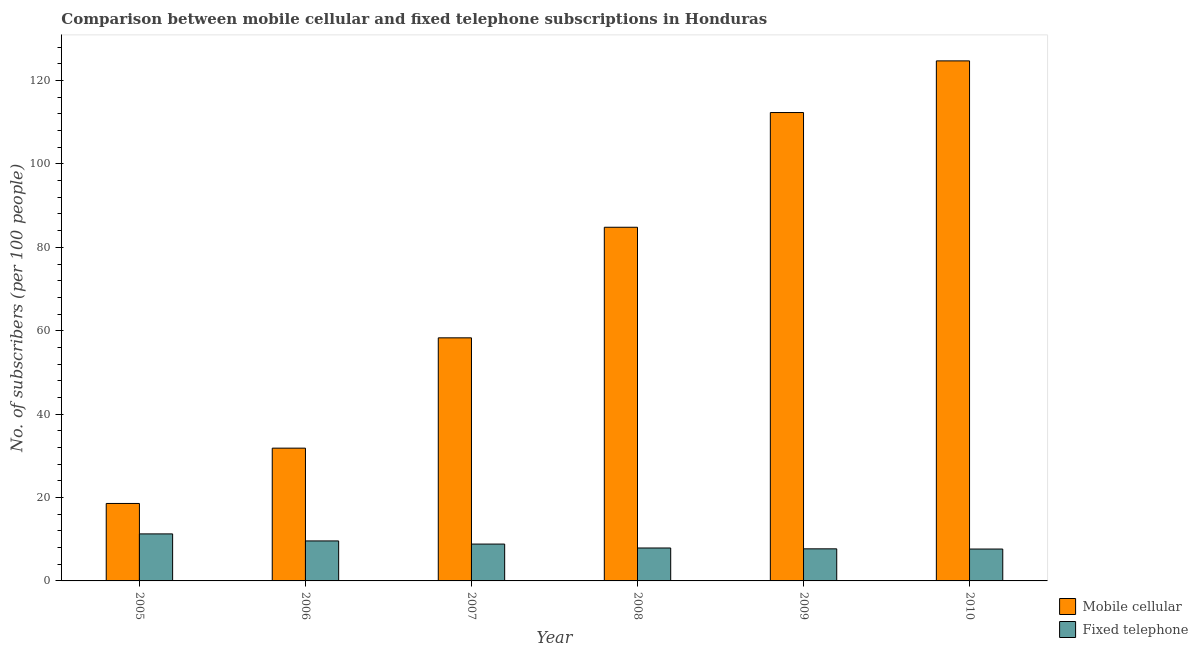How many groups of bars are there?
Keep it short and to the point. 6. Are the number of bars per tick equal to the number of legend labels?
Ensure brevity in your answer.  Yes. Are the number of bars on each tick of the X-axis equal?
Your answer should be compact. Yes. How many bars are there on the 6th tick from the left?
Your answer should be very brief. 2. How many bars are there on the 4th tick from the right?
Offer a very short reply. 2. What is the label of the 3rd group of bars from the left?
Your answer should be very brief. 2007. In how many cases, is the number of bars for a given year not equal to the number of legend labels?
Your answer should be very brief. 0. What is the number of mobile cellular subscribers in 2010?
Your response must be concise. 124.72. Across all years, what is the maximum number of mobile cellular subscribers?
Your answer should be very brief. 124.72. Across all years, what is the minimum number of fixed telephone subscribers?
Provide a succinct answer. 7.65. What is the total number of mobile cellular subscribers in the graph?
Offer a terse response. 430.58. What is the difference between the number of mobile cellular subscribers in 2008 and that in 2009?
Offer a very short reply. -27.51. What is the difference between the number of fixed telephone subscribers in 2008 and the number of mobile cellular subscribers in 2007?
Provide a succinct answer. -0.94. What is the average number of fixed telephone subscribers per year?
Your response must be concise. 8.82. In the year 2006, what is the difference between the number of fixed telephone subscribers and number of mobile cellular subscribers?
Your answer should be compact. 0. In how many years, is the number of mobile cellular subscribers greater than 116?
Provide a short and direct response. 1. What is the ratio of the number of fixed telephone subscribers in 2006 to that in 2008?
Your answer should be very brief. 1.21. Is the number of mobile cellular subscribers in 2005 less than that in 2010?
Your answer should be compact. Yes. Is the difference between the number of fixed telephone subscribers in 2006 and 2009 greater than the difference between the number of mobile cellular subscribers in 2006 and 2009?
Make the answer very short. No. What is the difference between the highest and the second highest number of mobile cellular subscribers?
Your answer should be compact. 12.39. What is the difference between the highest and the lowest number of fixed telephone subscribers?
Offer a terse response. 3.63. Is the sum of the number of mobile cellular subscribers in 2005 and 2010 greater than the maximum number of fixed telephone subscribers across all years?
Your answer should be very brief. Yes. What does the 1st bar from the left in 2007 represents?
Offer a terse response. Mobile cellular. What does the 2nd bar from the right in 2008 represents?
Keep it short and to the point. Mobile cellular. How many bars are there?
Offer a terse response. 12. Does the graph contain any zero values?
Give a very brief answer. No. How many legend labels are there?
Provide a succinct answer. 2. How are the legend labels stacked?
Offer a terse response. Vertical. What is the title of the graph?
Make the answer very short. Comparison between mobile cellular and fixed telephone subscriptions in Honduras. Does "Primary income" appear as one of the legend labels in the graph?
Your response must be concise. No. What is the label or title of the X-axis?
Your response must be concise. Year. What is the label or title of the Y-axis?
Your answer should be compact. No. of subscribers (per 100 people). What is the No. of subscribers (per 100 people) of Mobile cellular in 2005?
Keep it short and to the point. 18.58. What is the No. of subscribers (per 100 people) of Fixed telephone in 2005?
Offer a very short reply. 11.28. What is the No. of subscribers (per 100 people) in Mobile cellular in 2006?
Make the answer very short. 31.84. What is the No. of subscribers (per 100 people) in Fixed telephone in 2006?
Your response must be concise. 9.59. What is the No. of subscribers (per 100 people) of Mobile cellular in 2007?
Give a very brief answer. 58.3. What is the No. of subscribers (per 100 people) of Fixed telephone in 2007?
Make the answer very short. 8.84. What is the No. of subscribers (per 100 people) of Mobile cellular in 2008?
Offer a terse response. 84.82. What is the No. of subscribers (per 100 people) of Fixed telephone in 2008?
Your response must be concise. 7.9. What is the No. of subscribers (per 100 people) of Mobile cellular in 2009?
Keep it short and to the point. 112.33. What is the No. of subscribers (per 100 people) in Fixed telephone in 2009?
Make the answer very short. 7.69. What is the No. of subscribers (per 100 people) in Mobile cellular in 2010?
Your answer should be very brief. 124.72. What is the No. of subscribers (per 100 people) in Fixed telephone in 2010?
Ensure brevity in your answer.  7.65. Across all years, what is the maximum No. of subscribers (per 100 people) of Mobile cellular?
Provide a succinct answer. 124.72. Across all years, what is the maximum No. of subscribers (per 100 people) in Fixed telephone?
Provide a short and direct response. 11.28. Across all years, what is the minimum No. of subscribers (per 100 people) of Mobile cellular?
Offer a very short reply. 18.58. Across all years, what is the minimum No. of subscribers (per 100 people) of Fixed telephone?
Your response must be concise. 7.65. What is the total No. of subscribers (per 100 people) in Mobile cellular in the graph?
Offer a very short reply. 430.58. What is the total No. of subscribers (per 100 people) in Fixed telephone in the graph?
Keep it short and to the point. 52.94. What is the difference between the No. of subscribers (per 100 people) in Mobile cellular in 2005 and that in 2006?
Ensure brevity in your answer.  -13.27. What is the difference between the No. of subscribers (per 100 people) in Fixed telephone in 2005 and that in 2006?
Your answer should be compact. 1.69. What is the difference between the No. of subscribers (per 100 people) of Mobile cellular in 2005 and that in 2007?
Offer a very short reply. -39.72. What is the difference between the No. of subscribers (per 100 people) in Fixed telephone in 2005 and that in 2007?
Your answer should be compact. 2.44. What is the difference between the No. of subscribers (per 100 people) of Mobile cellular in 2005 and that in 2008?
Your response must be concise. -66.24. What is the difference between the No. of subscribers (per 100 people) of Fixed telephone in 2005 and that in 2008?
Make the answer very short. 3.38. What is the difference between the No. of subscribers (per 100 people) in Mobile cellular in 2005 and that in 2009?
Your answer should be very brief. -93.75. What is the difference between the No. of subscribers (per 100 people) of Fixed telephone in 2005 and that in 2009?
Keep it short and to the point. 3.58. What is the difference between the No. of subscribers (per 100 people) of Mobile cellular in 2005 and that in 2010?
Your answer should be very brief. -106.14. What is the difference between the No. of subscribers (per 100 people) in Fixed telephone in 2005 and that in 2010?
Your response must be concise. 3.63. What is the difference between the No. of subscribers (per 100 people) of Mobile cellular in 2006 and that in 2007?
Provide a succinct answer. -26.46. What is the difference between the No. of subscribers (per 100 people) of Fixed telephone in 2006 and that in 2007?
Your answer should be very brief. 0.75. What is the difference between the No. of subscribers (per 100 people) in Mobile cellular in 2006 and that in 2008?
Provide a short and direct response. -52.98. What is the difference between the No. of subscribers (per 100 people) in Fixed telephone in 2006 and that in 2008?
Offer a very short reply. 1.69. What is the difference between the No. of subscribers (per 100 people) in Mobile cellular in 2006 and that in 2009?
Offer a terse response. -80.49. What is the difference between the No. of subscribers (per 100 people) of Fixed telephone in 2006 and that in 2009?
Keep it short and to the point. 1.9. What is the difference between the No. of subscribers (per 100 people) of Mobile cellular in 2006 and that in 2010?
Make the answer very short. -92.88. What is the difference between the No. of subscribers (per 100 people) in Fixed telephone in 2006 and that in 2010?
Ensure brevity in your answer.  1.94. What is the difference between the No. of subscribers (per 100 people) of Mobile cellular in 2007 and that in 2008?
Your answer should be very brief. -26.52. What is the difference between the No. of subscribers (per 100 people) of Fixed telephone in 2007 and that in 2008?
Ensure brevity in your answer.  0.94. What is the difference between the No. of subscribers (per 100 people) of Mobile cellular in 2007 and that in 2009?
Ensure brevity in your answer.  -54.03. What is the difference between the No. of subscribers (per 100 people) of Fixed telephone in 2007 and that in 2009?
Give a very brief answer. 1.14. What is the difference between the No. of subscribers (per 100 people) of Mobile cellular in 2007 and that in 2010?
Provide a succinct answer. -66.42. What is the difference between the No. of subscribers (per 100 people) in Fixed telephone in 2007 and that in 2010?
Provide a short and direct response. 1.19. What is the difference between the No. of subscribers (per 100 people) in Mobile cellular in 2008 and that in 2009?
Keep it short and to the point. -27.51. What is the difference between the No. of subscribers (per 100 people) of Fixed telephone in 2008 and that in 2009?
Your answer should be compact. 0.21. What is the difference between the No. of subscribers (per 100 people) of Mobile cellular in 2008 and that in 2010?
Offer a terse response. -39.9. What is the difference between the No. of subscribers (per 100 people) of Fixed telephone in 2008 and that in 2010?
Provide a succinct answer. 0.25. What is the difference between the No. of subscribers (per 100 people) of Mobile cellular in 2009 and that in 2010?
Offer a very short reply. -12.39. What is the difference between the No. of subscribers (per 100 people) in Fixed telephone in 2009 and that in 2010?
Your answer should be very brief. 0.05. What is the difference between the No. of subscribers (per 100 people) of Mobile cellular in 2005 and the No. of subscribers (per 100 people) of Fixed telephone in 2006?
Ensure brevity in your answer.  8.99. What is the difference between the No. of subscribers (per 100 people) of Mobile cellular in 2005 and the No. of subscribers (per 100 people) of Fixed telephone in 2007?
Provide a short and direct response. 9.74. What is the difference between the No. of subscribers (per 100 people) in Mobile cellular in 2005 and the No. of subscribers (per 100 people) in Fixed telephone in 2008?
Ensure brevity in your answer.  10.68. What is the difference between the No. of subscribers (per 100 people) in Mobile cellular in 2005 and the No. of subscribers (per 100 people) in Fixed telephone in 2009?
Your response must be concise. 10.88. What is the difference between the No. of subscribers (per 100 people) in Mobile cellular in 2005 and the No. of subscribers (per 100 people) in Fixed telephone in 2010?
Your answer should be compact. 10.93. What is the difference between the No. of subscribers (per 100 people) of Mobile cellular in 2006 and the No. of subscribers (per 100 people) of Fixed telephone in 2007?
Provide a short and direct response. 23. What is the difference between the No. of subscribers (per 100 people) in Mobile cellular in 2006 and the No. of subscribers (per 100 people) in Fixed telephone in 2008?
Provide a succinct answer. 23.94. What is the difference between the No. of subscribers (per 100 people) in Mobile cellular in 2006 and the No. of subscribers (per 100 people) in Fixed telephone in 2009?
Ensure brevity in your answer.  24.15. What is the difference between the No. of subscribers (per 100 people) in Mobile cellular in 2006 and the No. of subscribers (per 100 people) in Fixed telephone in 2010?
Make the answer very short. 24.2. What is the difference between the No. of subscribers (per 100 people) of Mobile cellular in 2007 and the No. of subscribers (per 100 people) of Fixed telephone in 2008?
Keep it short and to the point. 50.4. What is the difference between the No. of subscribers (per 100 people) of Mobile cellular in 2007 and the No. of subscribers (per 100 people) of Fixed telephone in 2009?
Offer a terse response. 50.6. What is the difference between the No. of subscribers (per 100 people) in Mobile cellular in 2007 and the No. of subscribers (per 100 people) in Fixed telephone in 2010?
Provide a short and direct response. 50.65. What is the difference between the No. of subscribers (per 100 people) in Mobile cellular in 2008 and the No. of subscribers (per 100 people) in Fixed telephone in 2009?
Provide a short and direct response. 77.13. What is the difference between the No. of subscribers (per 100 people) in Mobile cellular in 2008 and the No. of subscribers (per 100 people) in Fixed telephone in 2010?
Give a very brief answer. 77.17. What is the difference between the No. of subscribers (per 100 people) of Mobile cellular in 2009 and the No. of subscribers (per 100 people) of Fixed telephone in 2010?
Make the answer very short. 104.68. What is the average No. of subscribers (per 100 people) in Mobile cellular per year?
Make the answer very short. 71.76. What is the average No. of subscribers (per 100 people) of Fixed telephone per year?
Keep it short and to the point. 8.82. In the year 2005, what is the difference between the No. of subscribers (per 100 people) in Mobile cellular and No. of subscribers (per 100 people) in Fixed telephone?
Your response must be concise. 7.3. In the year 2006, what is the difference between the No. of subscribers (per 100 people) in Mobile cellular and No. of subscribers (per 100 people) in Fixed telephone?
Your answer should be compact. 22.25. In the year 2007, what is the difference between the No. of subscribers (per 100 people) in Mobile cellular and No. of subscribers (per 100 people) in Fixed telephone?
Make the answer very short. 49.46. In the year 2008, what is the difference between the No. of subscribers (per 100 people) of Mobile cellular and No. of subscribers (per 100 people) of Fixed telephone?
Give a very brief answer. 76.92. In the year 2009, what is the difference between the No. of subscribers (per 100 people) of Mobile cellular and No. of subscribers (per 100 people) of Fixed telephone?
Provide a short and direct response. 104.64. In the year 2010, what is the difference between the No. of subscribers (per 100 people) in Mobile cellular and No. of subscribers (per 100 people) in Fixed telephone?
Ensure brevity in your answer.  117.07. What is the ratio of the No. of subscribers (per 100 people) of Mobile cellular in 2005 to that in 2006?
Give a very brief answer. 0.58. What is the ratio of the No. of subscribers (per 100 people) of Fixed telephone in 2005 to that in 2006?
Offer a terse response. 1.18. What is the ratio of the No. of subscribers (per 100 people) in Mobile cellular in 2005 to that in 2007?
Your answer should be very brief. 0.32. What is the ratio of the No. of subscribers (per 100 people) in Fixed telephone in 2005 to that in 2007?
Offer a very short reply. 1.28. What is the ratio of the No. of subscribers (per 100 people) of Mobile cellular in 2005 to that in 2008?
Your response must be concise. 0.22. What is the ratio of the No. of subscribers (per 100 people) in Fixed telephone in 2005 to that in 2008?
Keep it short and to the point. 1.43. What is the ratio of the No. of subscribers (per 100 people) in Mobile cellular in 2005 to that in 2009?
Offer a very short reply. 0.17. What is the ratio of the No. of subscribers (per 100 people) of Fixed telephone in 2005 to that in 2009?
Ensure brevity in your answer.  1.47. What is the ratio of the No. of subscribers (per 100 people) in Mobile cellular in 2005 to that in 2010?
Ensure brevity in your answer.  0.15. What is the ratio of the No. of subscribers (per 100 people) in Fixed telephone in 2005 to that in 2010?
Ensure brevity in your answer.  1.48. What is the ratio of the No. of subscribers (per 100 people) of Mobile cellular in 2006 to that in 2007?
Give a very brief answer. 0.55. What is the ratio of the No. of subscribers (per 100 people) of Fixed telephone in 2006 to that in 2007?
Provide a short and direct response. 1.09. What is the ratio of the No. of subscribers (per 100 people) in Mobile cellular in 2006 to that in 2008?
Make the answer very short. 0.38. What is the ratio of the No. of subscribers (per 100 people) in Fixed telephone in 2006 to that in 2008?
Offer a terse response. 1.21. What is the ratio of the No. of subscribers (per 100 people) of Mobile cellular in 2006 to that in 2009?
Offer a very short reply. 0.28. What is the ratio of the No. of subscribers (per 100 people) of Fixed telephone in 2006 to that in 2009?
Make the answer very short. 1.25. What is the ratio of the No. of subscribers (per 100 people) of Mobile cellular in 2006 to that in 2010?
Make the answer very short. 0.26. What is the ratio of the No. of subscribers (per 100 people) of Fixed telephone in 2006 to that in 2010?
Your response must be concise. 1.25. What is the ratio of the No. of subscribers (per 100 people) in Mobile cellular in 2007 to that in 2008?
Provide a succinct answer. 0.69. What is the ratio of the No. of subscribers (per 100 people) of Fixed telephone in 2007 to that in 2008?
Offer a terse response. 1.12. What is the ratio of the No. of subscribers (per 100 people) of Mobile cellular in 2007 to that in 2009?
Your answer should be compact. 0.52. What is the ratio of the No. of subscribers (per 100 people) of Fixed telephone in 2007 to that in 2009?
Your answer should be very brief. 1.15. What is the ratio of the No. of subscribers (per 100 people) of Mobile cellular in 2007 to that in 2010?
Offer a terse response. 0.47. What is the ratio of the No. of subscribers (per 100 people) of Fixed telephone in 2007 to that in 2010?
Your answer should be very brief. 1.16. What is the ratio of the No. of subscribers (per 100 people) of Mobile cellular in 2008 to that in 2009?
Offer a very short reply. 0.76. What is the ratio of the No. of subscribers (per 100 people) in Fixed telephone in 2008 to that in 2009?
Your response must be concise. 1.03. What is the ratio of the No. of subscribers (per 100 people) of Mobile cellular in 2008 to that in 2010?
Ensure brevity in your answer.  0.68. What is the ratio of the No. of subscribers (per 100 people) of Fixed telephone in 2008 to that in 2010?
Ensure brevity in your answer.  1.03. What is the ratio of the No. of subscribers (per 100 people) in Mobile cellular in 2009 to that in 2010?
Offer a terse response. 0.9. What is the ratio of the No. of subscribers (per 100 people) of Fixed telephone in 2009 to that in 2010?
Offer a very short reply. 1.01. What is the difference between the highest and the second highest No. of subscribers (per 100 people) in Mobile cellular?
Provide a succinct answer. 12.39. What is the difference between the highest and the second highest No. of subscribers (per 100 people) in Fixed telephone?
Your answer should be very brief. 1.69. What is the difference between the highest and the lowest No. of subscribers (per 100 people) of Mobile cellular?
Provide a succinct answer. 106.14. What is the difference between the highest and the lowest No. of subscribers (per 100 people) of Fixed telephone?
Your answer should be compact. 3.63. 